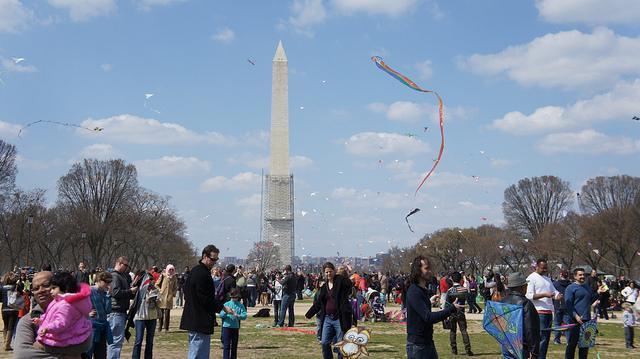How many people are there?
Give a very brief answer. 7. 